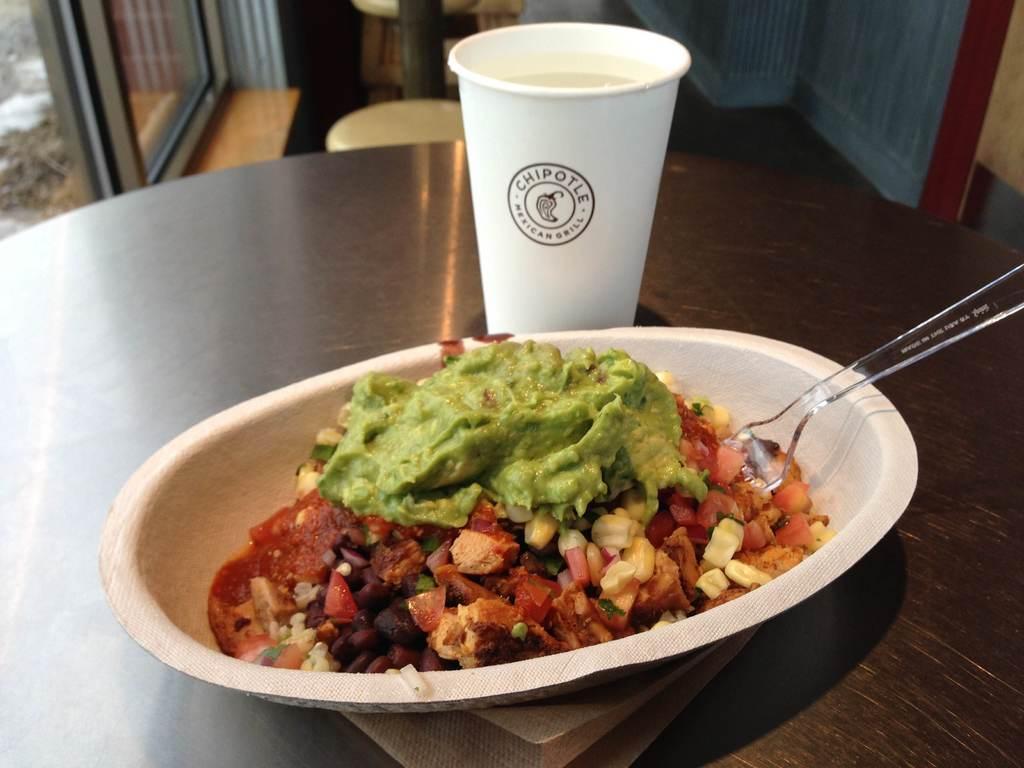In one or two sentences, can you explain what this image depicts? In this image at the bottom there is one table, on the table there is one bowl and in that bowl there is some food and one spoon beside the bowl there is one cup. And in the background there is a window, chairs, wall and some objects. 